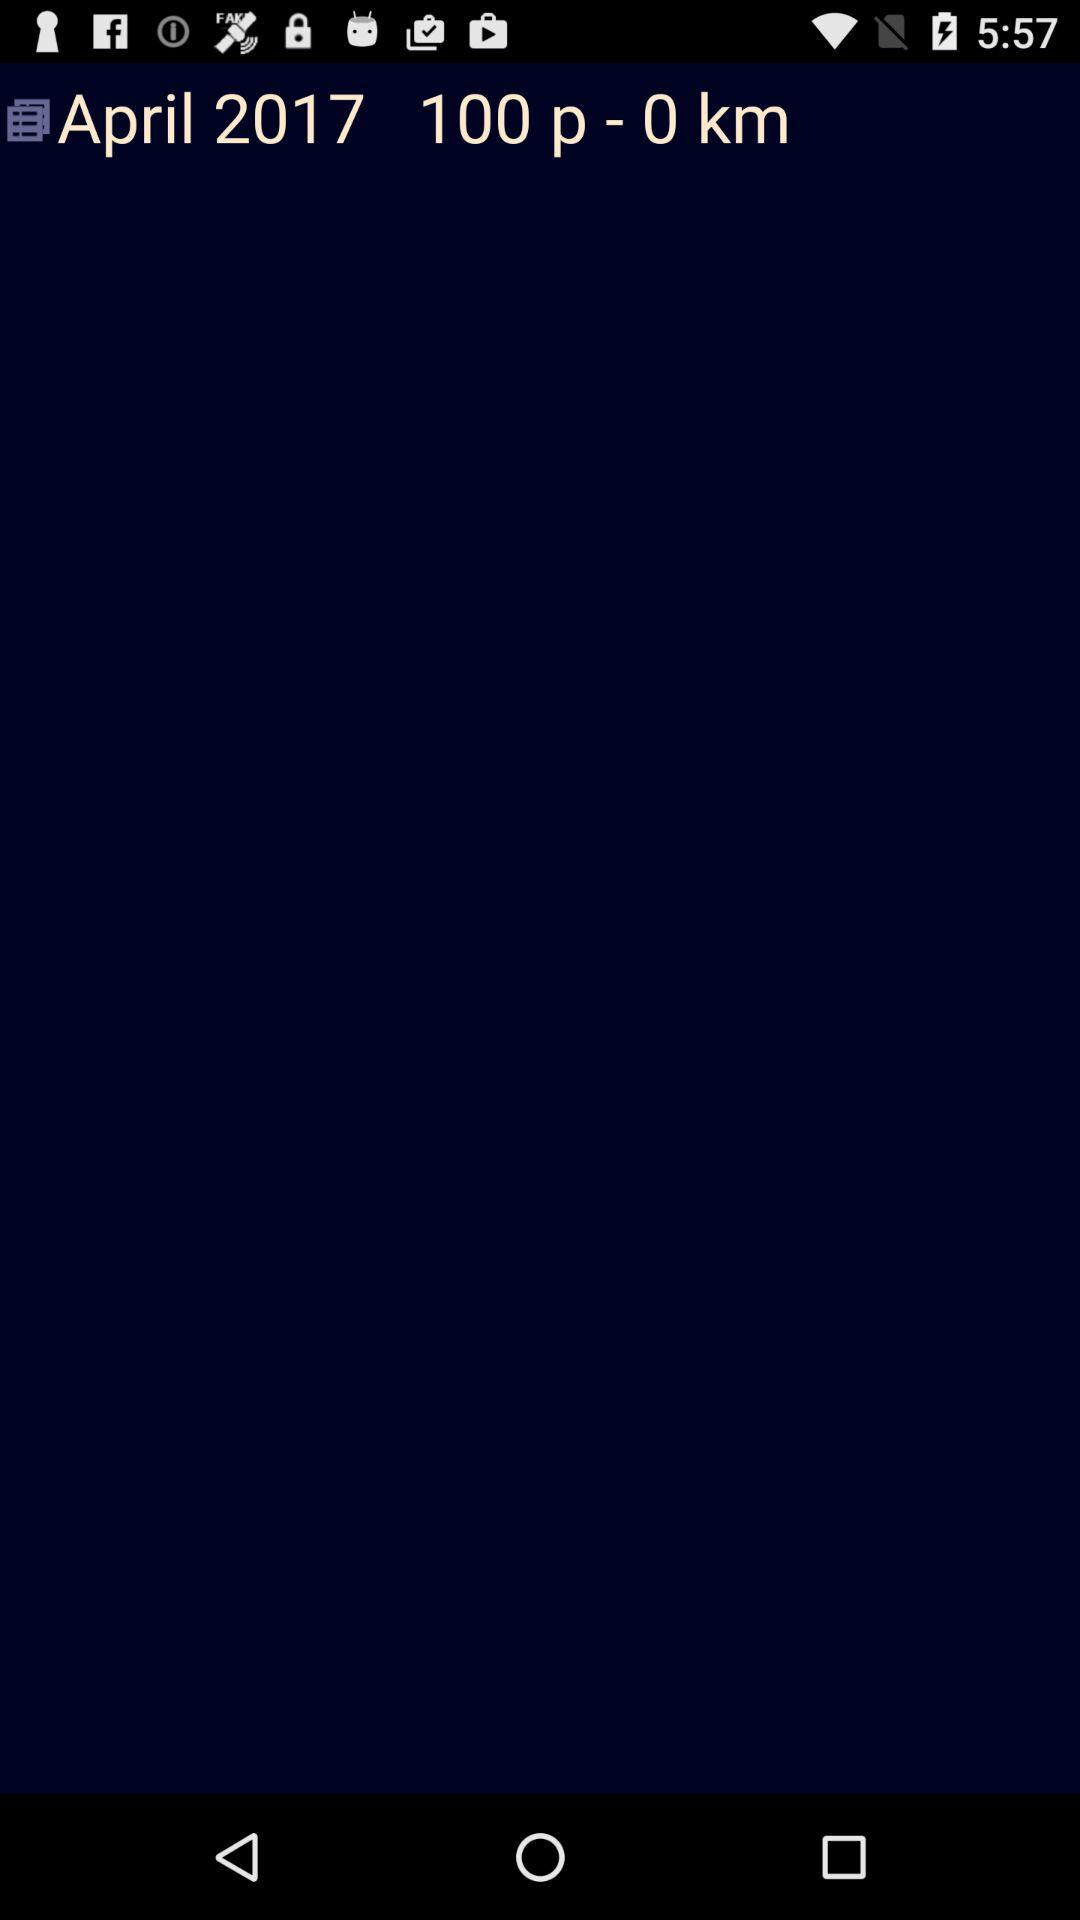What year is given? The given year is 2017. 